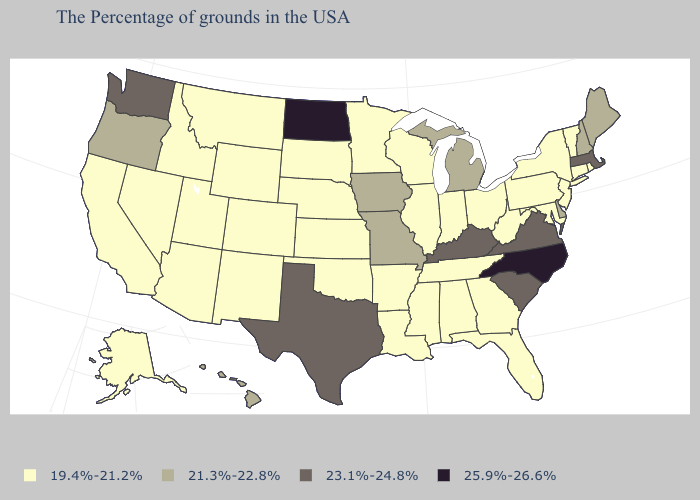Does Nevada have the lowest value in the West?
Write a very short answer. Yes. Is the legend a continuous bar?
Be succinct. No. What is the value of Kentucky?
Short answer required. 23.1%-24.8%. What is the value of South Carolina?
Short answer required. 23.1%-24.8%. Does the first symbol in the legend represent the smallest category?
Answer briefly. Yes. Does Alabama have the same value as Pennsylvania?
Give a very brief answer. Yes. Does North Dakota have the highest value in the MidWest?
Short answer required. Yes. What is the lowest value in states that border Tennessee?
Quick response, please. 19.4%-21.2%. Does Nevada have the same value as Maine?
Concise answer only. No. What is the value of Delaware?
Concise answer only. 21.3%-22.8%. Does Montana have a higher value than Idaho?
Give a very brief answer. No. Name the states that have a value in the range 19.4%-21.2%?
Answer briefly. Rhode Island, Vermont, Connecticut, New York, New Jersey, Maryland, Pennsylvania, West Virginia, Ohio, Florida, Georgia, Indiana, Alabama, Tennessee, Wisconsin, Illinois, Mississippi, Louisiana, Arkansas, Minnesota, Kansas, Nebraska, Oklahoma, South Dakota, Wyoming, Colorado, New Mexico, Utah, Montana, Arizona, Idaho, Nevada, California, Alaska. What is the value of Oklahoma?
Be succinct. 19.4%-21.2%. What is the value of Ohio?
Keep it brief. 19.4%-21.2%. 